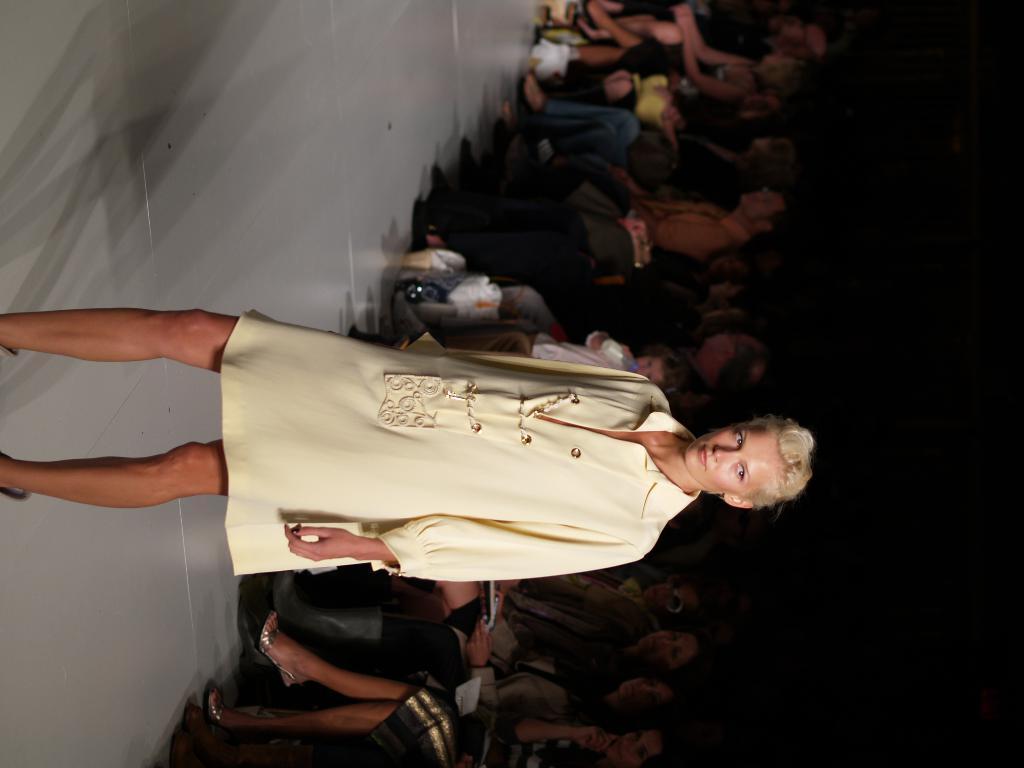Could you give a brief overview of what you see in this image? In this picture we can see a woman standing on the floor and at the back of her we can see a group of people, some objects and in the background it is dark. 